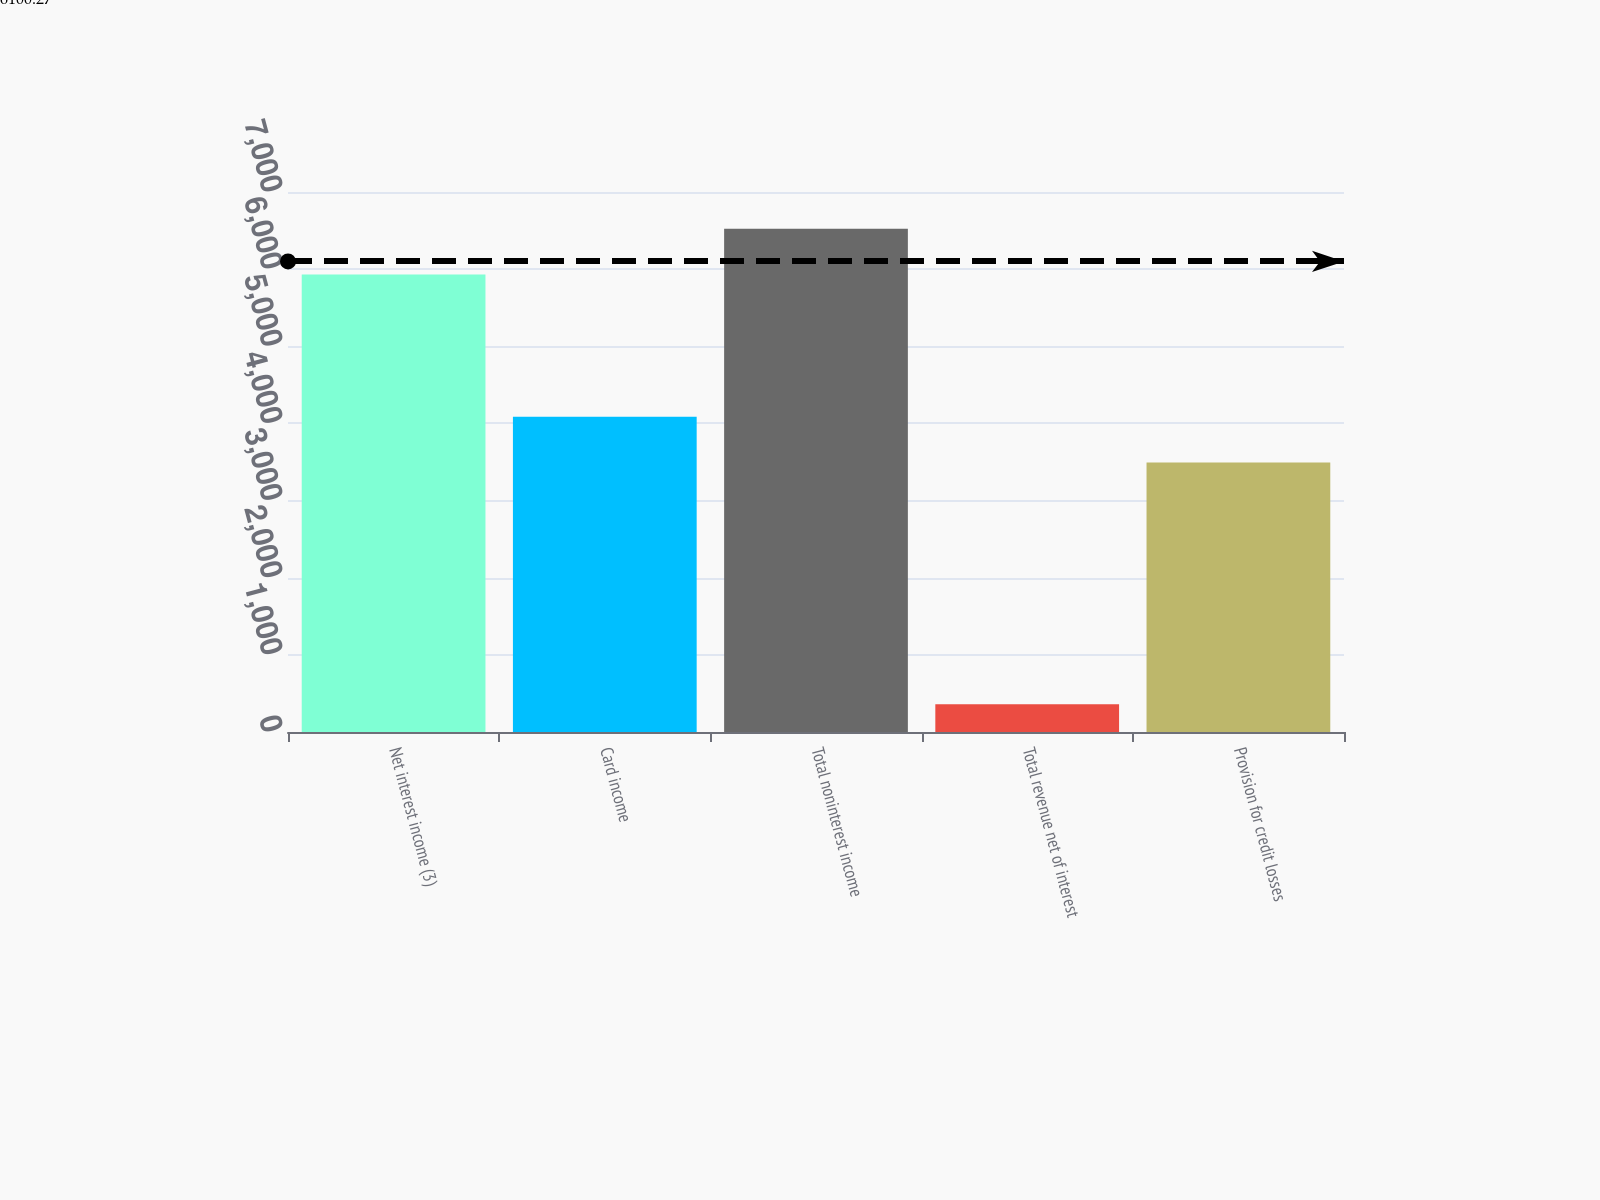Convert chart. <chart><loc_0><loc_0><loc_500><loc_500><bar_chart><fcel>Net interest income (3)<fcel>Card income<fcel>Total noninterest income<fcel>Total revenue net of interest<fcel>Provision for credit losses<nl><fcel>5930<fcel>4087<fcel>6523<fcel>360<fcel>3494<nl></chart> 